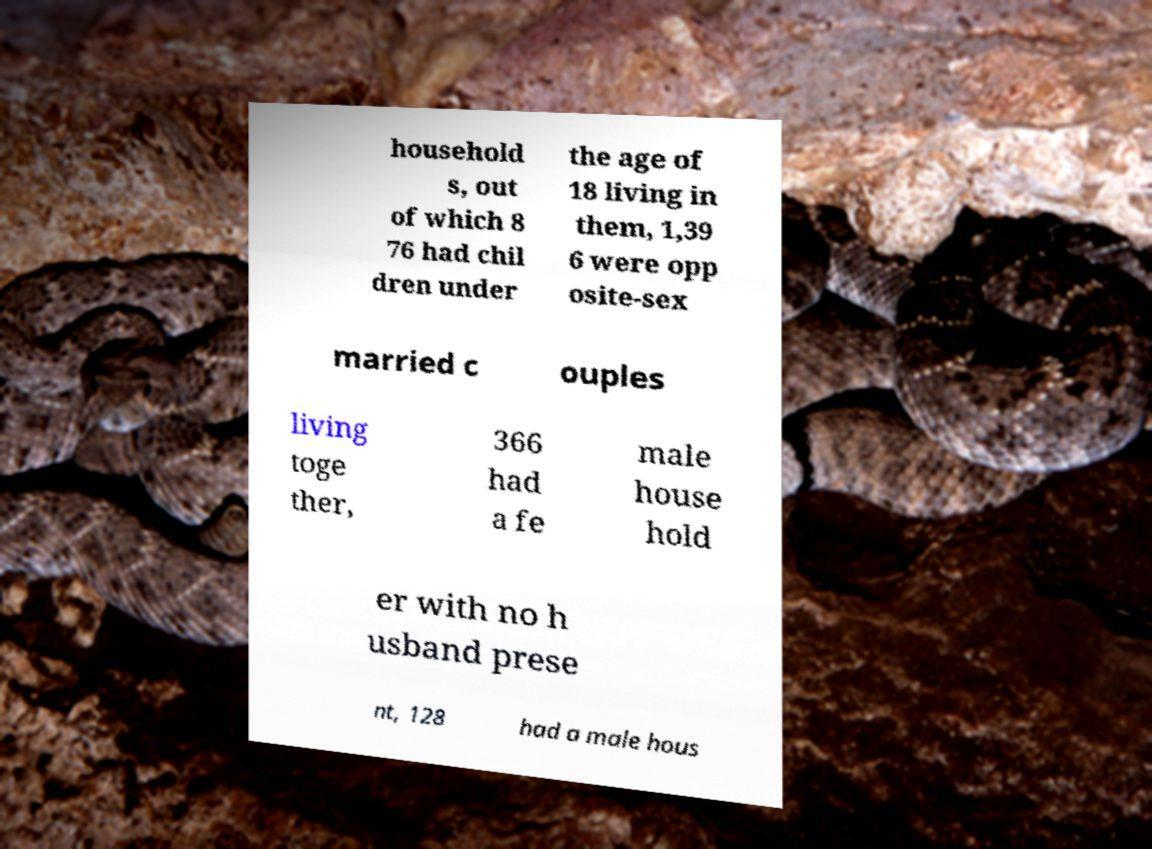Could you extract and type out the text from this image? household s, out of which 8 76 had chil dren under the age of 18 living in them, 1,39 6 were opp osite-sex married c ouples living toge ther, 366 had a fe male house hold er with no h usband prese nt, 128 had a male hous 